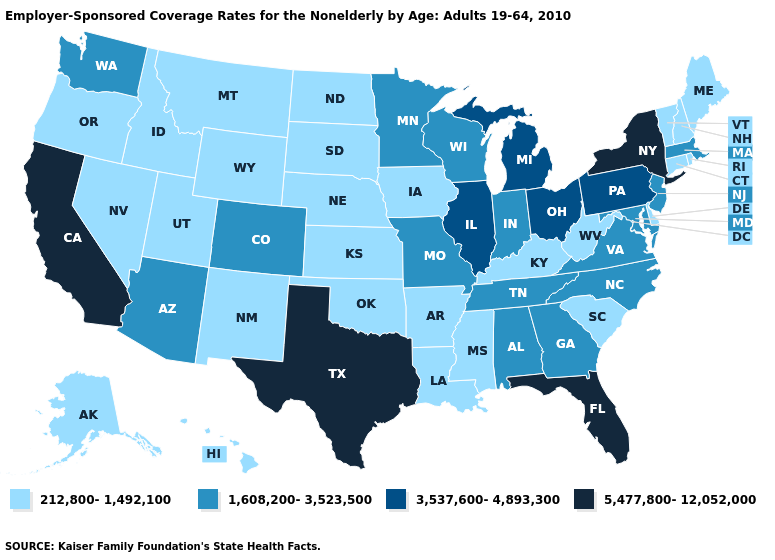What is the value of Nevada?
Answer briefly. 212,800-1,492,100. Name the states that have a value in the range 212,800-1,492,100?
Answer briefly. Alaska, Arkansas, Connecticut, Delaware, Hawaii, Idaho, Iowa, Kansas, Kentucky, Louisiana, Maine, Mississippi, Montana, Nebraska, Nevada, New Hampshire, New Mexico, North Dakota, Oklahoma, Oregon, Rhode Island, South Carolina, South Dakota, Utah, Vermont, West Virginia, Wyoming. How many symbols are there in the legend?
Short answer required. 4. Among the states that border Michigan , which have the highest value?
Quick response, please. Ohio. Name the states that have a value in the range 3,537,600-4,893,300?
Give a very brief answer. Illinois, Michigan, Ohio, Pennsylvania. What is the lowest value in states that border Indiana?
Keep it brief. 212,800-1,492,100. Which states have the highest value in the USA?
Keep it brief. California, Florida, New York, Texas. What is the value of Rhode Island?
Answer briefly. 212,800-1,492,100. What is the lowest value in the USA?
Give a very brief answer. 212,800-1,492,100. Among the states that border Arkansas , does Oklahoma have the highest value?
Short answer required. No. What is the lowest value in states that border Colorado?
Short answer required. 212,800-1,492,100. What is the highest value in the Northeast ?
Concise answer only. 5,477,800-12,052,000. Name the states that have a value in the range 5,477,800-12,052,000?
Give a very brief answer. California, Florida, New York, Texas. Name the states that have a value in the range 3,537,600-4,893,300?
Keep it brief. Illinois, Michigan, Ohio, Pennsylvania. Does Massachusetts have the highest value in the Northeast?
Write a very short answer. No. 